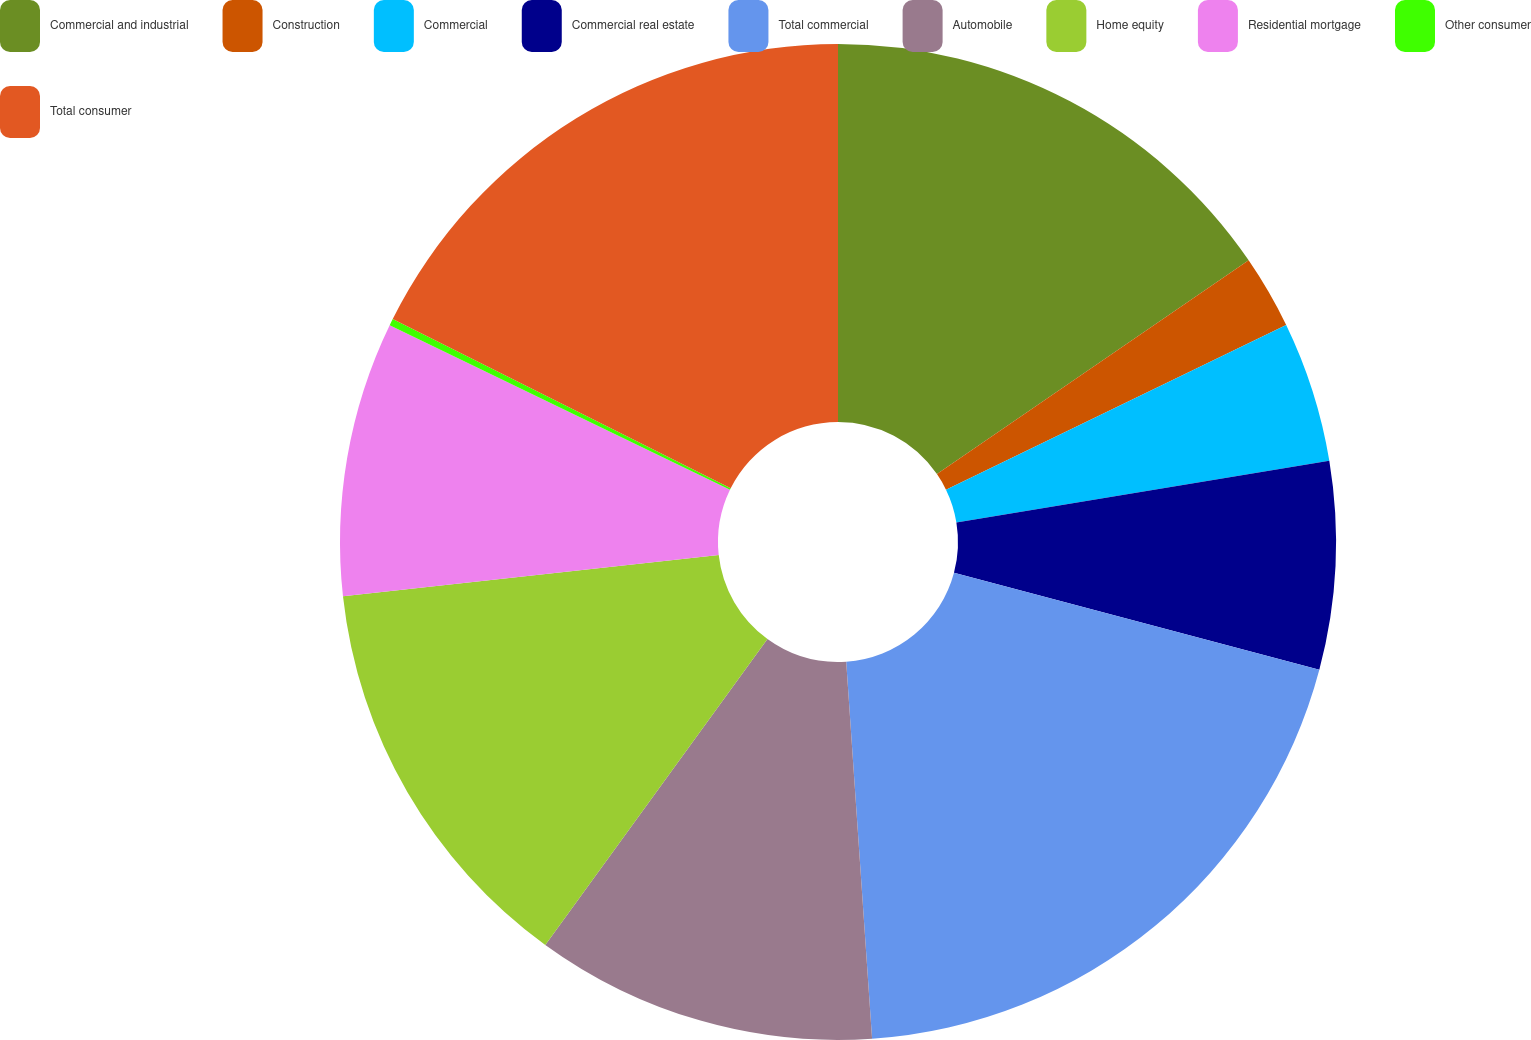<chart> <loc_0><loc_0><loc_500><loc_500><pie_chart><fcel>Commercial and industrial<fcel>Construction<fcel>Commercial<fcel>Commercial real estate<fcel>Total commercial<fcel>Automobile<fcel>Home equity<fcel>Residential mortgage<fcel>Other consumer<fcel>Total consumer<nl><fcel>15.43%<fcel>2.39%<fcel>4.57%<fcel>6.74%<fcel>19.78%<fcel>11.09%<fcel>13.26%<fcel>8.91%<fcel>0.22%<fcel>17.61%<nl></chart> 